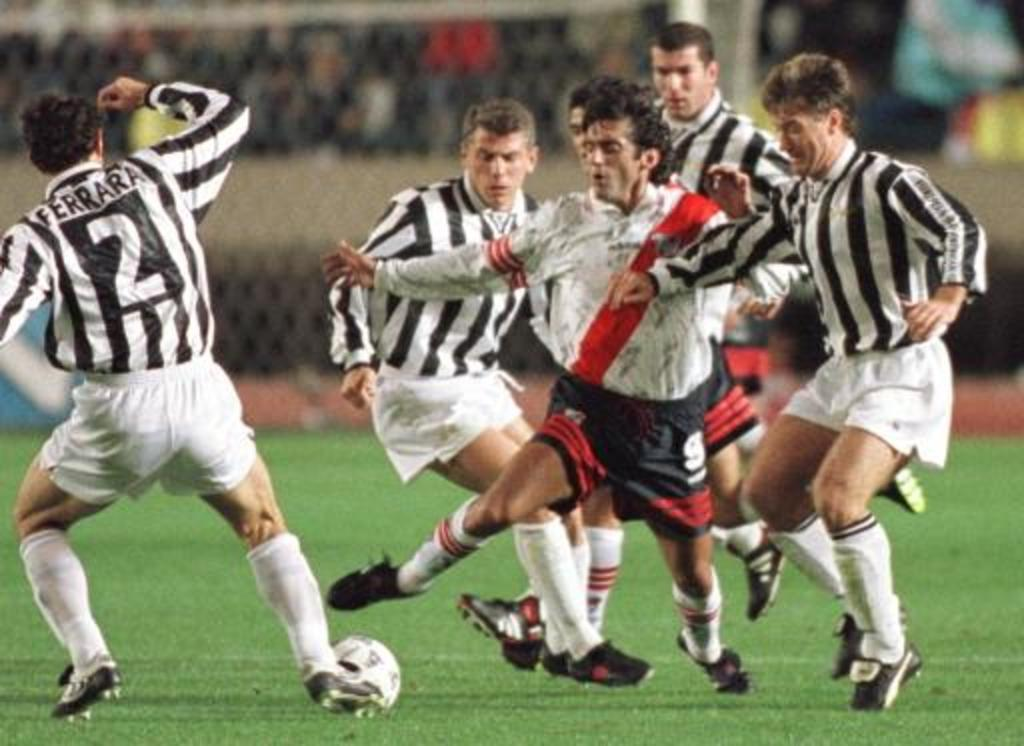Provide a one-sentence caption for the provided image. Several soccer players run up to steal the ball from number 2. 